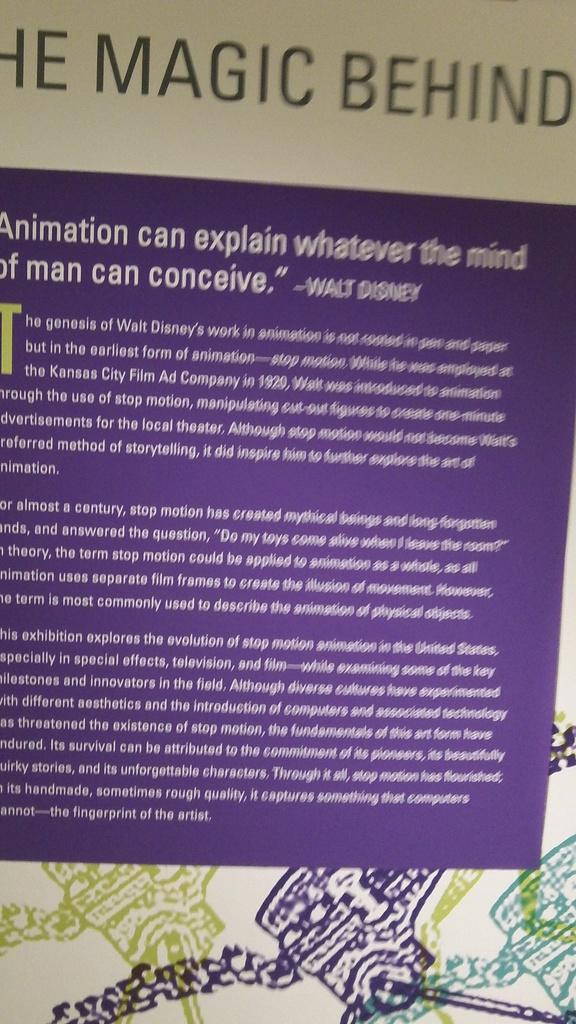<image>
Describe the image concisely. A purple sheet with the magic behind on it 